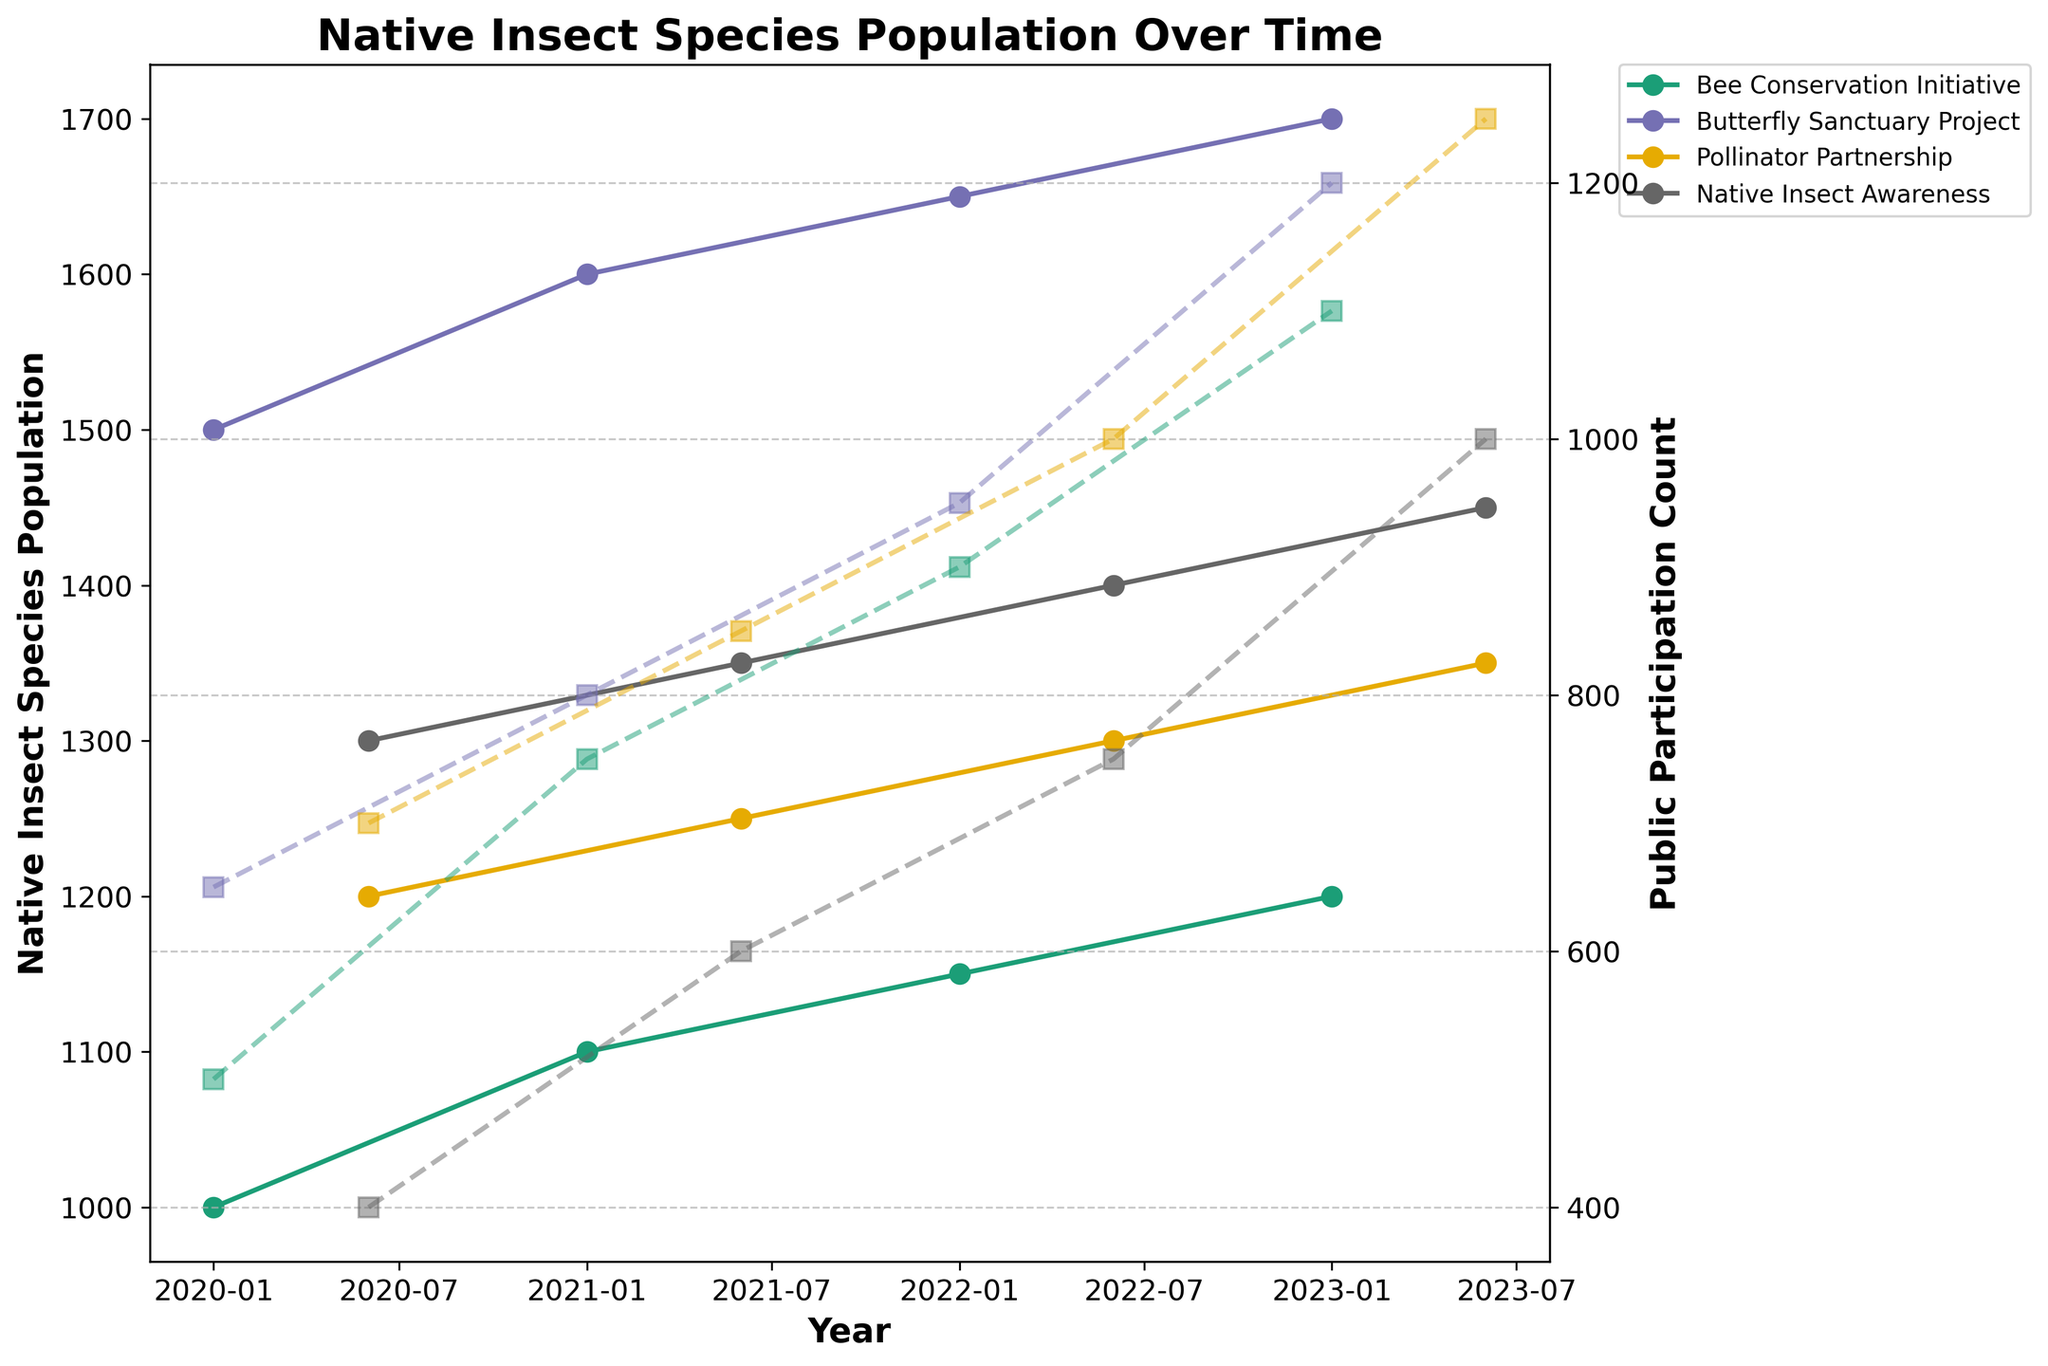What is the title of the figure? The title can be found at the top of the figure, indicating the main focus of the plot.
Answer: Native Insect Species Population Over Time Which program has the highest Native Insect Species Population in January 2023? Identify the data points for January 2023 and compare the Native Insect Species Population values for each program.
Answer: Butterfly Sanctuary Project How does the Native Insect Species Population in California change from January 2020 to June 2023? Look at the data points for the "Bee Conservation Initiative" program from January 2020 to June 2023, noting the population values at each date.
Answer: It increases from 1000 to 1200 What trend can be observed in the Native Insect Species Population for the "Pollinator Partnership" between June 2020 and June 2023? Focus on the data points for "Pollinator Partnership" from June 2020 to June 2023, and observe the direction of the trend.
Answer: The population generally increases Which region has the highest public participation count in June 2023? Locate the data points for June 2023 and compare the public participation counts for each region.
Answer: Florida Is there a correlation between public participation and Native Insect Species Population for the "Native Insect Awareness" program from 2020 to 2023? For the "Native Insect Awareness" program, compare the trends in public participation counts with the trends in Native Insect Species Population over the same period.
Answer: Yes, an increase in public participation correlates with an increase in Native Insect Species Population What is the difference in public participation count for the "Bee Conservation Initiative" between January 2020 and January 2023? Identify the public participation counts for January 2020 and January 2023 for the "Bee Conservation Initiative" and calculate the difference.
Answer: 600 Which program shows the most consistent increase in Native Insect Species Population over the years? Evaluate the trend lines for each program to identify the one with the most consistent upward trajectory.
Answer: Butterfly Sanctuary Project What was the Native Insect Species Population for the "Native Insect Awareness" program in June 2021? Locate the data point for June 2021 specifically for the "Native Insect Awareness" program.
Answer: 1350 How many data points are there for each program? Count the number of data points (distinct dates) for one program and infer the same for others.
Answer: 4 